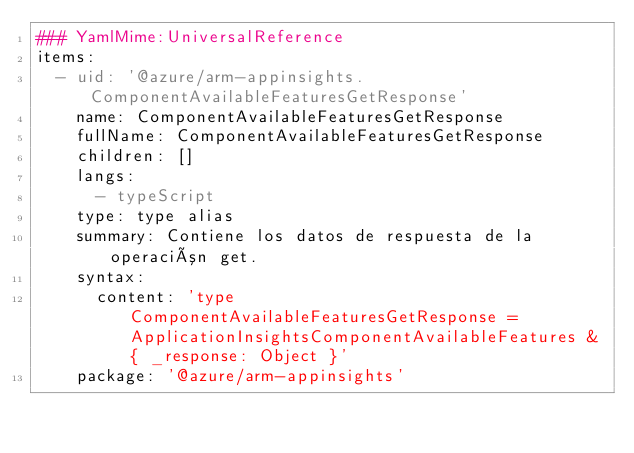<code> <loc_0><loc_0><loc_500><loc_500><_YAML_>### YamlMime:UniversalReference
items:
  - uid: '@azure/arm-appinsights.ComponentAvailableFeaturesGetResponse'
    name: ComponentAvailableFeaturesGetResponse
    fullName: ComponentAvailableFeaturesGetResponse
    children: []
    langs:
      - typeScript
    type: type alias
    summary: Contiene los datos de respuesta de la operación get.
    syntax:
      content: 'type ComponentAvailableFeaturesGetResponse = ApplicationInsightsComponentAvailableFeatures & { _response: Object }'
    package: '@azure/arm-appinsights'</code> 